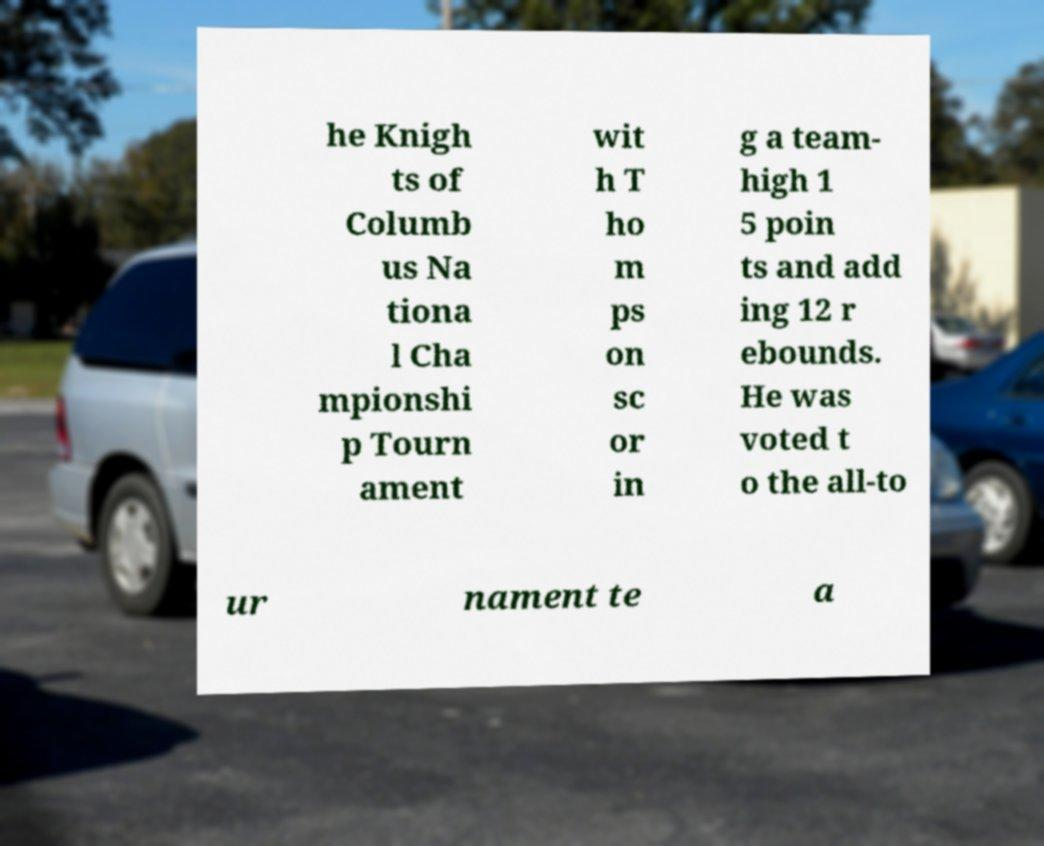Could you extract and type out the text from this image? he Knigh ts of Columb us Na tiona l Cha mpionshi p Tourn ament wit h T ho m ps on sc or in g a team- high 1 5 poin ts and add ing 12 r ebounds. He was voted t o the all-to ur nament te a 